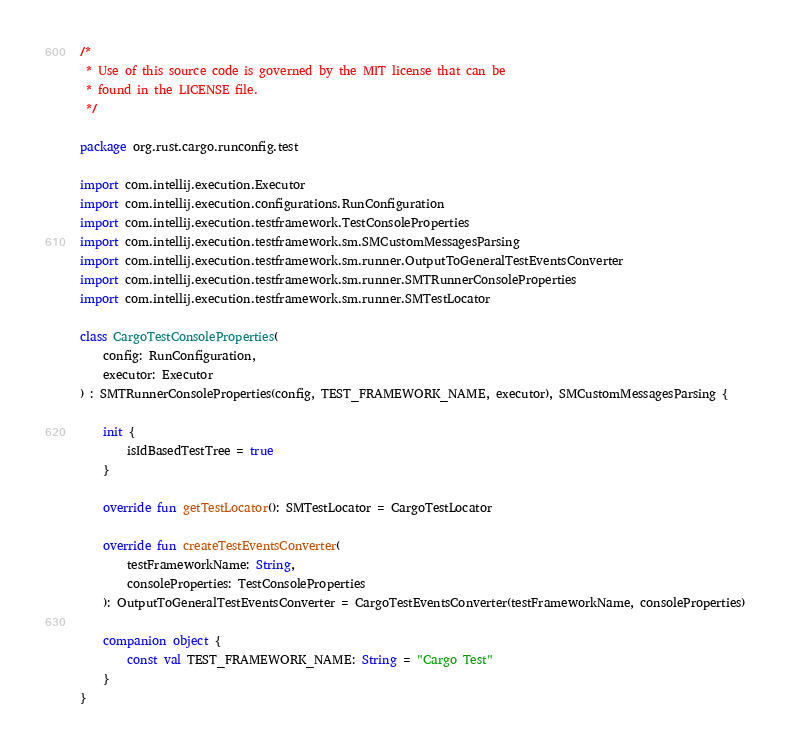Convert code to text. <code><loc_0><loc_0><loc_500><loc_500><_Kotlin_>/*
 * Use of this source code is governed by the MIT license that can be
 * found in the LICENSE file.
 */

package org.rust.cargo.runconfig.test

import com.intellij.execution.Executor
import com.intellij.execution.configurations.RunConfiguration
import com.intellij.execution.testframework.TestConsoleProperties
import com.intellij.execution.testframework.sm.SMCustomMessagesParsing
import com.intellij.execution.testframework.sm.runner.OutputToGeneralTestEventsConverter
import com.intellij.execution.testframework.sm.runner.SMTRunnerConsoleProperties
import com.intellij.execution.testframework.sm.runner.SMTestLocator

class CargoTestConsoleProperties(
    config: RunConfiguration,
    executor: Executor
) : SMTRunnerConsoleProperties(config, TEST_FRAMEWORK_NAME, executor), SMCustomMessagesParsing {

    init {
        isIdBasedTestTree = true
    }

    override fun getTestLocator(): SMTestLocator = CargoTestLocator

    override fun createTestEventsConverter(
        testFrameworkName: String,
        consoleProperties: TestConsoleProperties
    ): OutputToGeneralTestEventsConverter = CargoTestEventsConverter(testFrameworkName, consoleProperties)

    companion object {
        const val TEST_FRAMEWORK_NAME: String = "Cargo Test"
    }
}
</code> 